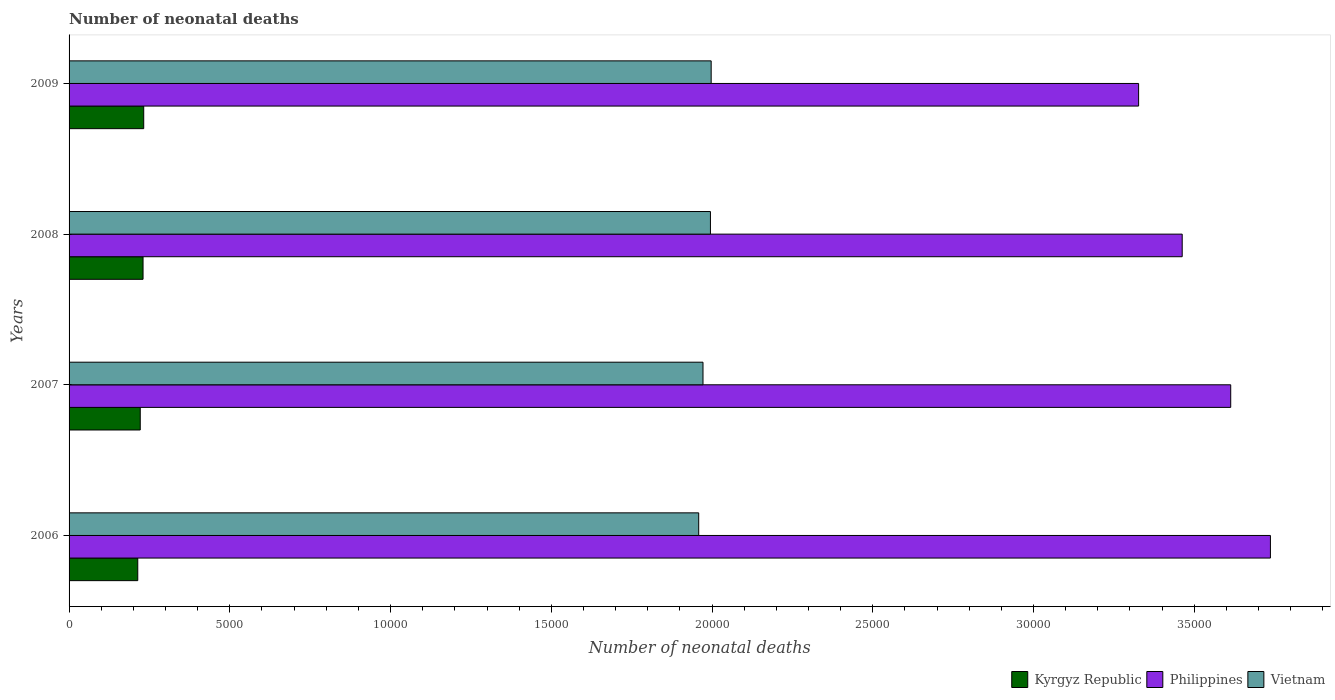How many different coloured bars are there?
Your answer should be very brief. 3. How many groups of bars are there?
Offer a terse response. 4. Are the number of bars per tick equal to the number of legend labels?
Make the answer very short. Yes. In how many cases, is the number of bars for a given year not equal to the number of legend labels?
Ensure brevity in your answer.  0. What is the number of neonatal deaths in in Vietnam in 2006?
Make the answer very short. 1.96e+04. Across all years, what is the maximum number of neonatal deaths in in Vietnam?
Keep it short and to the point. 2.00e+04. Across all years, what is the minimum number of neonatal deaths in in Philippines?
Your answer should be very brief. 3.33e+04. What is the total number of neonatal deaths in in Philippines in the graph?
Make the answer very short. 1.41e+05. What is the difference between the number of neonatal deaths in in Vietnam in 2006 and that in 2008?
Offer a very short reply. -365. What is the difference between the number of neonatal deaths in in Kyrgyz Republic in 2009 and the number of neonatal deaths in in Vietnam in 2008?
Your response must be concise. -1.76e+04. What is the average number of neonatal deaths in in Philippines per year?
Offer a very short reply. 3.53e+04. In the year 2008, what is the difference between the number of neonatal deaths in in Kyrgyz Republic and number of neonatal deaths in in Philippines?
Ensure brevity in your answer.  -3.23e+04. In how many years, is the number of neonatal deaths in in Kyrgyz Republic greater than 17000 ?
Your answer should be compact. 0. What is the ratio of the number of neonatal deaths in in Philippines in 2007 to that in 2008?
Ensure brevity in your answer.  1.04. Is the number of neonatal deaths in in Philippines in 2006 less than that in 2007?
Your response must be concise. No. What is the difference between the highest and the second highest number of neonatal deaths in in Vietnam?
Your response must be concise. 23. What is the difference between the highest and the lowest number of neonatal deaths in in Vietnam?
Your answer should be compact. 388. In how many years, is the number of neonatal deaths in in Philippines greater than the average number of neonatal deaths in in Philippines taken over all years?
Your response must be concise. 2. Is the sum of the number of neonatal deaths in in Philippines in 2007 and 2009 greater than the maximum number of neonatal deaths in in Kyrgyz Republic across all years?
Make the answer very short. Yes. What does the 1st bar from the top in 2007 represents?
Make the answer very short. Vietnam. What does the 2nd bar from the bottom in 2006 represents?
Your answer should be compact. Philippines. How many bars are there?
Provide a succinct answer. 12. Are all the bars in the graph horizontal?
Ensure brevity in your answer.  Yes. What is the difference between two consecutive major ticks on the X-axis?
Provide a succinct answer. 5000. How many legend labels are there?
Make the answer very short. 3. How are the legend labels stacked?
Your answer should be very brief. Horizontal. What is the title of the graph?
Ensure brevity in your answer.  Number of neonatal deaths. Does "Indonesia" appear as one of the legend labels in the graph?
Your answer should be compact. No. What is the label or title of the X-axis?
Make the answer very short. Number of neonatal deaths. What is the Number of neonatal deaths in Kyrgyz Republic in 2006?
Your answer should be very brief. 2137. What is the Number of neonatal deaths of Philippines in 2006?
Ensure brevity in your answer.  3.74e+04. What is the Number of neonatal deaths in Vietnam in 2006?
Give a very brief answer. 1.96e+04. What is the Number of neonatal deaths in Kyrgyz Republic in 2007?
Give a very brief answer. 2214. What is the Number of neonatal deaths in Philippines in 2007?
Ensure brevity in your answer.  3.61e+04. What is the Number of neonatal deaths of Vietnam in 2007?
Provide a succinct answer. 1.97e+04. What is the Number of neonatal deaths of Kyrgyz Republic in 2008?
Offer a terse response. 2301. What is the Number of neonatal deaths in Philippines in 2008?
Make the answer very short. 3.46e+04. What is the Number of neonatal deaths of Vietnam in 2008?
Your answer should be very brief. 2.00e+04. What is the Number of neonatal deaths in Kyrgyz Republic in 2009?
Offer a very short reply. 2322. What is the Number of neonatal deaths of Philippines in 2009?
Your answer should be compact. 3.33e+04. What is the Number of neonatal deaths in Vietnam in 2009?
Keep it short and to the point. 2.00e+04. Across all years, what is the maximum Number of neonatal deaths of Kyrgyz Republic?
Offer a terse response. 2322. Across all years, what is the maximum Number of neonatal deaths in Philippines?
Offer a very short reply. 3.74e+04. Across all years, what is the maximum Number of neonatal deaths of Vietnam?
Give a very brief answer. 2.00e+04. Across all years, what is the minimum Number of neonatal deaths of Kyrgyz Republic?
Keep it short and to the point. 2137. Across all years, what is the minimum Number of neonatal deaths of Philippines?
Your answer should be very brief. 3.33e+04. Across all years, what is the minimum Number of neonatal deaths in Vietnam?
Ensure brevity in your answer.  1.96e+04. What is the total Number of neonatal deaths in Kyrgyz Republic in the graph?
Ensure brevity in your answer.  8974. What is the total Number of neonatal deaths of Philippines in the graph?
Make the answer very short. 1.41e+05. What is the total Number of neonatal deaths in Vietnam in the graph?
Provide a short and direct response. 7.92e+04. What is the difference between the Number of neonatal deaths in Kyrgyz Republic in 2006 and that in 2007?
Give a very brief answer. -77. What is the difference between the Number of neonatal deaths in Philippines in 2006 and that in 2007?
Offer a terse response. 1235. What is the difference between the Number of neonatal deaths in Vietnam in 2006 and that in 2007?
Make the answer very short. -134. What is the difference between the Number of neonatal deaths of Kyrgyz Republic in 2006 and that in 2008?
Provide a short and direct response. -164. What is the difference between the Number of neonatal deaths of Philippines in 2006 and that in 2008?
Your answer should be very brief. 2744. What is the difference between the Number of neonatal deaths in Vietnam in 2006 and that in 2008?
Offer a terse response. -365. What is the difference between the Number of neonatal deaths in Kyrgyz Republic in 2006 and that in 2009?
Your answer should be very brief. -185. What is the difference between the Number of neonatal deaths of Philippines in 2006 and that in 2009?
Provide a short and direct response. 4100. What is the difference between the Number of neonatal deaths in Vietnam in 2006 and that in 2009?
Your response must be concise. -388. What is the difference between the Number of neonatal deaths of Kyrgyz Republic in 2007 and that in 2008?
Offer a terse response. -87. What is the difference between the Number of neonatal deaths of Philippines in 2007 and that in 2008?
Give a very brief answer. 1509. What is the difference between the Number of neonatal deaths of Vietnam in 2007 and that in 2008?
Offer a very short reply. -231. What is the difference between the Number of neonatal deaths of Kyrgyz Republic in 2007 and that in 2009?
Your answer should be compact. -108. What is the difference between the Number of neonatal deaths in Philippines in 2007 and that in 2009?
Make the answer very short. 2865. What is the difference between the Number of neonatal deaths in Vietnam in 2007 and that in 2009?
Keep it short and to the point. -254. What is the difference between the Number of neonatal deaths in Philippines in 2008 and that in 2009?
Offer a very short reply. 1356. What is the difference between the Number of neonatal deaths in Kyrgyz Republic in 2006 and the Number of neonatal deaths in Philippines in 2007?
Make the answer very short. -3.40e+04. What is the difference between the Number of neonatal deaths in Kyrgyz Republic in 2006 and the Number of neonatal deaths in Vietnam in 2007?
Your answer should be compact. -1.76e+04. What is the difference between the Number of neonatal deaths of Philippines in 2006 and the Number of neonatal deaths of Vietnam in 2007?
Your answer should be very brief. 1.76e+04. What is the difference between the Number of neonatal deaths of Kyrgyz Republic in 2006 and the Number of neonatal deaths of Philippines in 2008?
Keep it short and to the point. -3.25e+04. What is the difference between the Number of neonatal deaths of Kyrgyz Republic in 2006 and the Number of neonatal deaths of Vietnam in 2008?
Offer a terse response. -1.78e+04. What is the difference between the Number of neonatal deaths in Philippines in 2006 and the Number of neonatal deaths in Vietnam in 2008?
Your response must be concise. 1.74e+04. What is the difference between the Number of neonatal deaths in Kyrgyz Republic in 2006 and the Number of neonatal deaths in Philippines in 2009?
Offer a very short reply. -3.11e+04. What is the difference between the Number of neonatal deaths of Kyrgyz Republic in 2006 and the Number of neonatal deaths of Vietnam in 2009?
Ensure brevity in your answer.  -1.78e+04. What is the difference between the Number of neonatal deaths in Philippines in 2006 and the Number of neonatal deaths in Vietnam in 2009?
Keep it short and to the point. 1.74e+04. What is the difference between the Number of neonatal deaths of Kyrgyz Republic in 2007 and the Number of neonatal deaths of Philippines in 2008?
Offer a very short reply. -3.24e+04. What is the difference between the Number of neonatal deaths of Kyrgyz Republic in 2007 and the Number of neonatal deaths of Vietnam in 2008?
Your response must be concise. -1.77e+04. What is the difference between the Number of neonatal deaths of Philippines in 2007 and the Number of neonatal deaths of Vietnam in 2008?
Provide a succinct answer. 1.62e+04. What is the difference between the Number of neonatal deaths in Kyrgyz Republic in 2007 and the Number of neonatal deaths in Philippines in 2009?
Provide a succinct answer. -3.11e+04. What is the difference between the Number of neonatal deaths of Kyrgyz Republic in 2007 and the Number of neonatal deaths of Vietnam in 2009?
Provide a short and direct response. -1.78e+04. What is the difference between the Number of neonatal deaths in Philippines in 2007 and the Number of neonatal deaths in Vietnam in 2009?
Keep it short and to the point. 1.62e+04. What is the difference between the Number of neonatal deaths of Kyrgyz Republic in 2008 and the Number of neonatal deaths of Philippines in 2009?
Provide a short and direct response. -3.10e+04. What is the difference between the Number of neonatal deaths in Kyrgyz Republic in 2008 and the Number of neonatal deaths in Vietnam in 2009?
Your answer should be compact. -1.77e+04. What is the difference between the Number of neonatal deaths in Philippines in 2008 and the Number of neonatal deaths in Vietnam in 2009?
Your response must be concise. 1.47e+04. What is the average Number of neonatal deaths of Kyrgyz Republic per year?
Make the answer very short. 2243.5. What is the average Number of neonatal deaths in Philippines per year?
Your answer should be very brief. 3.53e+04. What is the average Number of neonatal deaths of Vietnam per year?
Your answer should be compact. 1.98e+04. In the year 2006, what is the difference between the Number of neonatal deaths of Kyrgyz Republic and Number of neonatal deaths of Philippines?
Your answer should be very brief. -3.52e+04. In the year 2006, what is the difference between the Number of neonatal deaths of Kyrgyz Republic and Number of neonatal deaths of Vietnam?
Keep it short and to the point. -1.74e+04. In the year 2006, what is the difference between the Number of neonatal deaths in Philippines and Number of neonatal deaths in Vietnam?
Ensure brevity in your answer.  1.78e+04. In the year 2007, what is the difference between the Number of neonatal deaths in Kyrgyz Republic and Number of neonatal deaths in Philippines?
Ensure brevity in your answer.  -3.39e+04. In the year 2007, what is the difference between the Number of neonatal deaths in Kyrgyz Republic and Number of neonatal deaths in Vietnam?
Ensure brevity in your answer.  -1.75e+04. In the year 2007, what is the difference between the Number of neonatal deaths of Philippines and Number of neonatal deaths of Vietnam?
Provide a succinct answer. 1.64e+04. In the year 2008, what is the difference between the Number of neonatal deaths of Kyrgyz Republic and Number of neonatal deaths of Philippines?
Your answer should be compact. -3.23e+04. In the year 2008, what is the difference between the Number of neonatal deaths of Kyrgyz Republic and Number of neonatal deaths of Vietnam?
Give a very brief answer. -1.76e+04. In the year 2008, what is the difference between the Number of neonatal deaths in Philippines and Number of neonatal deaths in Vietnam?
Give a very brief answer. 1.47e+04. In the year 2009, what is the difference between the Number of neonatal deaths of Kyrgyz Republic and Number of neonatal deaths of Philippines?
Your answer should be very brief. -3.09e+04. In the year 2009, what is the difference between the Number of neonatal deaths of Kyrgyz Republic and Number of neonatal deaths of Vietnam?
Your response must be concise. -1.77e+04. In the year 2009, what is the difference between the Number of neonatal deaths of Philippines and Number of neonatal deaths of Vietnam?
Offer a terse response. 1.33e+04. What is the ratio of the Number of neonatal deaths in Kyrgyz Republic in 2006 to that in 2007?
Provide a succinct answer. 0.97. What is the ratio of the Number of neonatal deaths in Philippines in 2006 to that in 2007?
Your answer should be compact. 1.03. What is the ratio of the Number of neonatal deaths in Kyrgyz Republic in 2006 to that in 2008?
Your response must be concise. 0.93. What is the ratio of the Number of neonatal deaths of Philippines in 2006 to that in 2008?
Provide a succinct answer. 1.08. What is the ratio of the Number of neonatal deaths of Vietnam in 2006 to that in 2008?
Give a very brief answer. 0.98. What is the ratio of the Number of neonatal deaths of Kyrgyz Republic in 2006 to that in 2009?
Provide a succinct answer. 0.92. What is the ratio of the Number of neonatal deaths in Philippines in 2006 to that in 2009?
Make the answer very short. 1.12. What is the ratio of the Number of neonatal deaths in Vietnam in 2006 to that in 2009?
Your answer should be compact. 0.98. What is the ratio of the Number of neonatal deaths of Kyrgyz Republic in 2007 to that in 2008?
Offer a terse response. 0.96. What is the ratio of the Number of neonatal deaths of Philippines in 2007 to that in 2008?
Make the answer very short. 1.04. What is the ratio of the Number of neonatal deaths of Vietnam in 2007 to that in 2008?
Give a very brief answer. 0.99. What is the ratio of the Number of neonatal deaths in Kyrgyz Republic in 2007 to that in 2009?
Ensure brevity in your answer.  0.95. What is the ratio of the Number of neonatal deaths of Philippines in 2007 to that in 2009?
Offer a terse response. 1.09. What is the ratio of the Number of neonatal deaths of Vietnam in 2007 to that in 2009?
Make the answer very short. 0.99. What is the ratio of the Number of neonatal deaths in Philippines in 2008 to that in 2009?
Your answer should be very brief. 1.04. What is the ratio of the Number of neonatal deaths in Vietnam in 2008 to that in 2009?
Make the answer very short. 1. What is the difference between the highest and the second highest Number of neonatal deaths of Philippines?
Keep it short and to the point. 1235. What is the difference between the highest and the second highest Number of neonatal deaths in Vietnam?
Keep it short and to the point. 23. What is the difference between the highest and the lowest Number of neonatal deaths in Kyrgyz Republic?
Give a very brief answer. 185. What is the difference between the highest and the lowest Number of neonatal deaths of Philippines?
Make the answer very short. 4100. What is the difference between the highest and the lowest Number of neonatal deaths in Vietnam?
Make the answer very short. 388. 